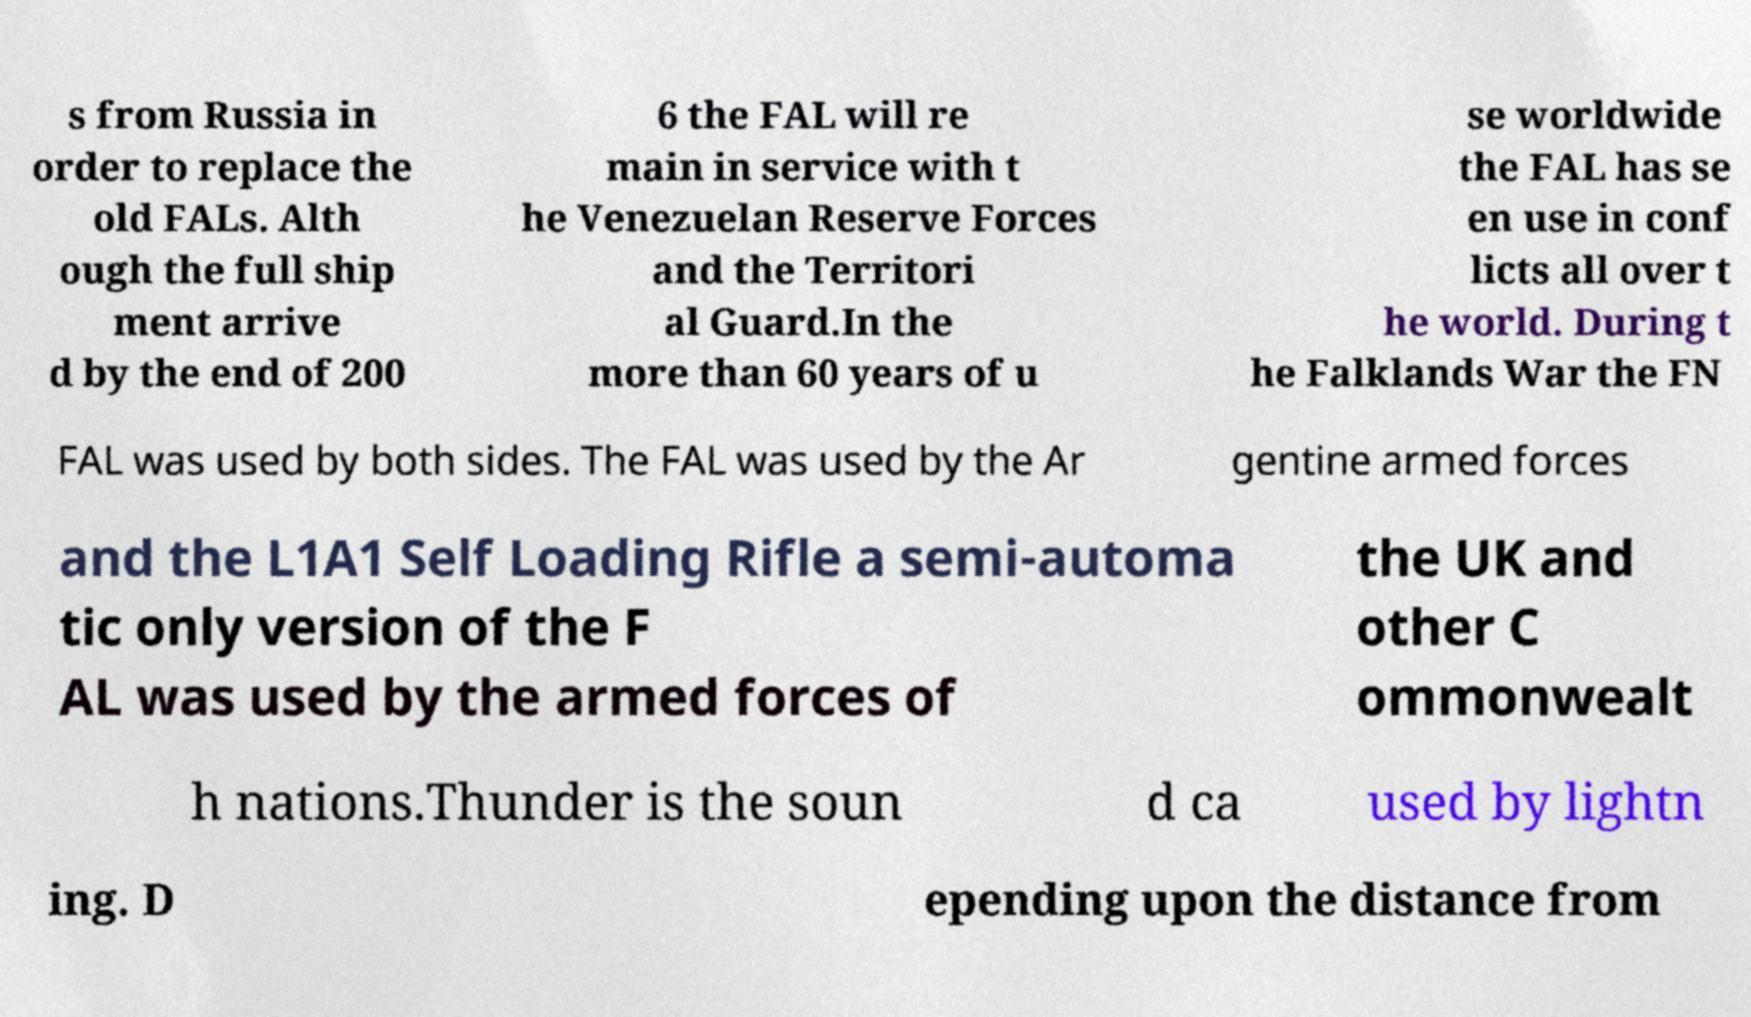Can you read and provide the text displayed in the image?This photo seems to have some interesting text. Can you extract and type it out for me? s from Russia in order to replace the old FALs. Alth ough the full ship ment arrive d by the end of 200 6 the FAL will re main in service with t he Venezuelan Reserve Forces and the Territori al Guard.In the more than 60 years of u se worldwide the FAL has se en use in conf licts all over t he world. During t he Falklands War the FN FAL was used by both sides. The FAL was used by the Ar gentine armed forces and the L1A1 Self Loading Rifle a semi-automa tic only version of the F AL was used by the armed forces of the UK and other C ommonwealt h nations.Thunder is the soun d ca used by lightn ing. D epending upon the distance from 